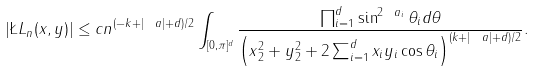Convert formula to latex. <formula><loc_0><loc_0><loc_500><loc_500>| \L L _ { n } ( x , y ) | \leq c n ^ { ( - k + | \ a | + d ) / 2 } \int _ { [ 0 , \pi ] ^ { d } } \frac { \prod _ { i = 1 } ^ { d } \sin ^ { 2 \ a _ { i } } \theta _ { i } d \theta } { \left ( \| x \| _ { 2 } ^ { 2 } + \| y \| _ { 2 } ^ { 2 } + 2 \sum _ { i = 1 } ^ { d } x _ { i } y _ { i } \cos \theta _ { i } \right ) ^ { ( k + | \ a | + d ) / 2 } } .</formula> 